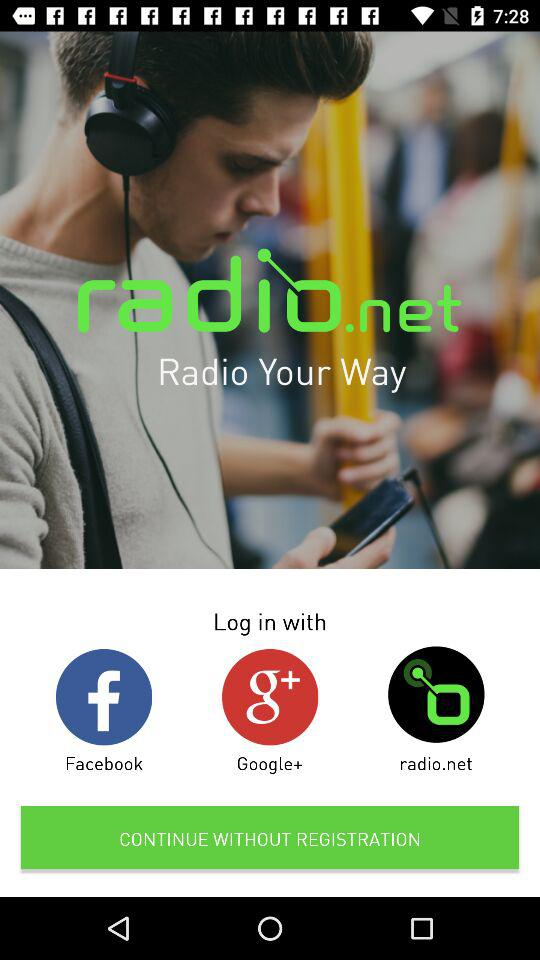How many navigation items are there?
Answer the question using a single word or phrase. 3 